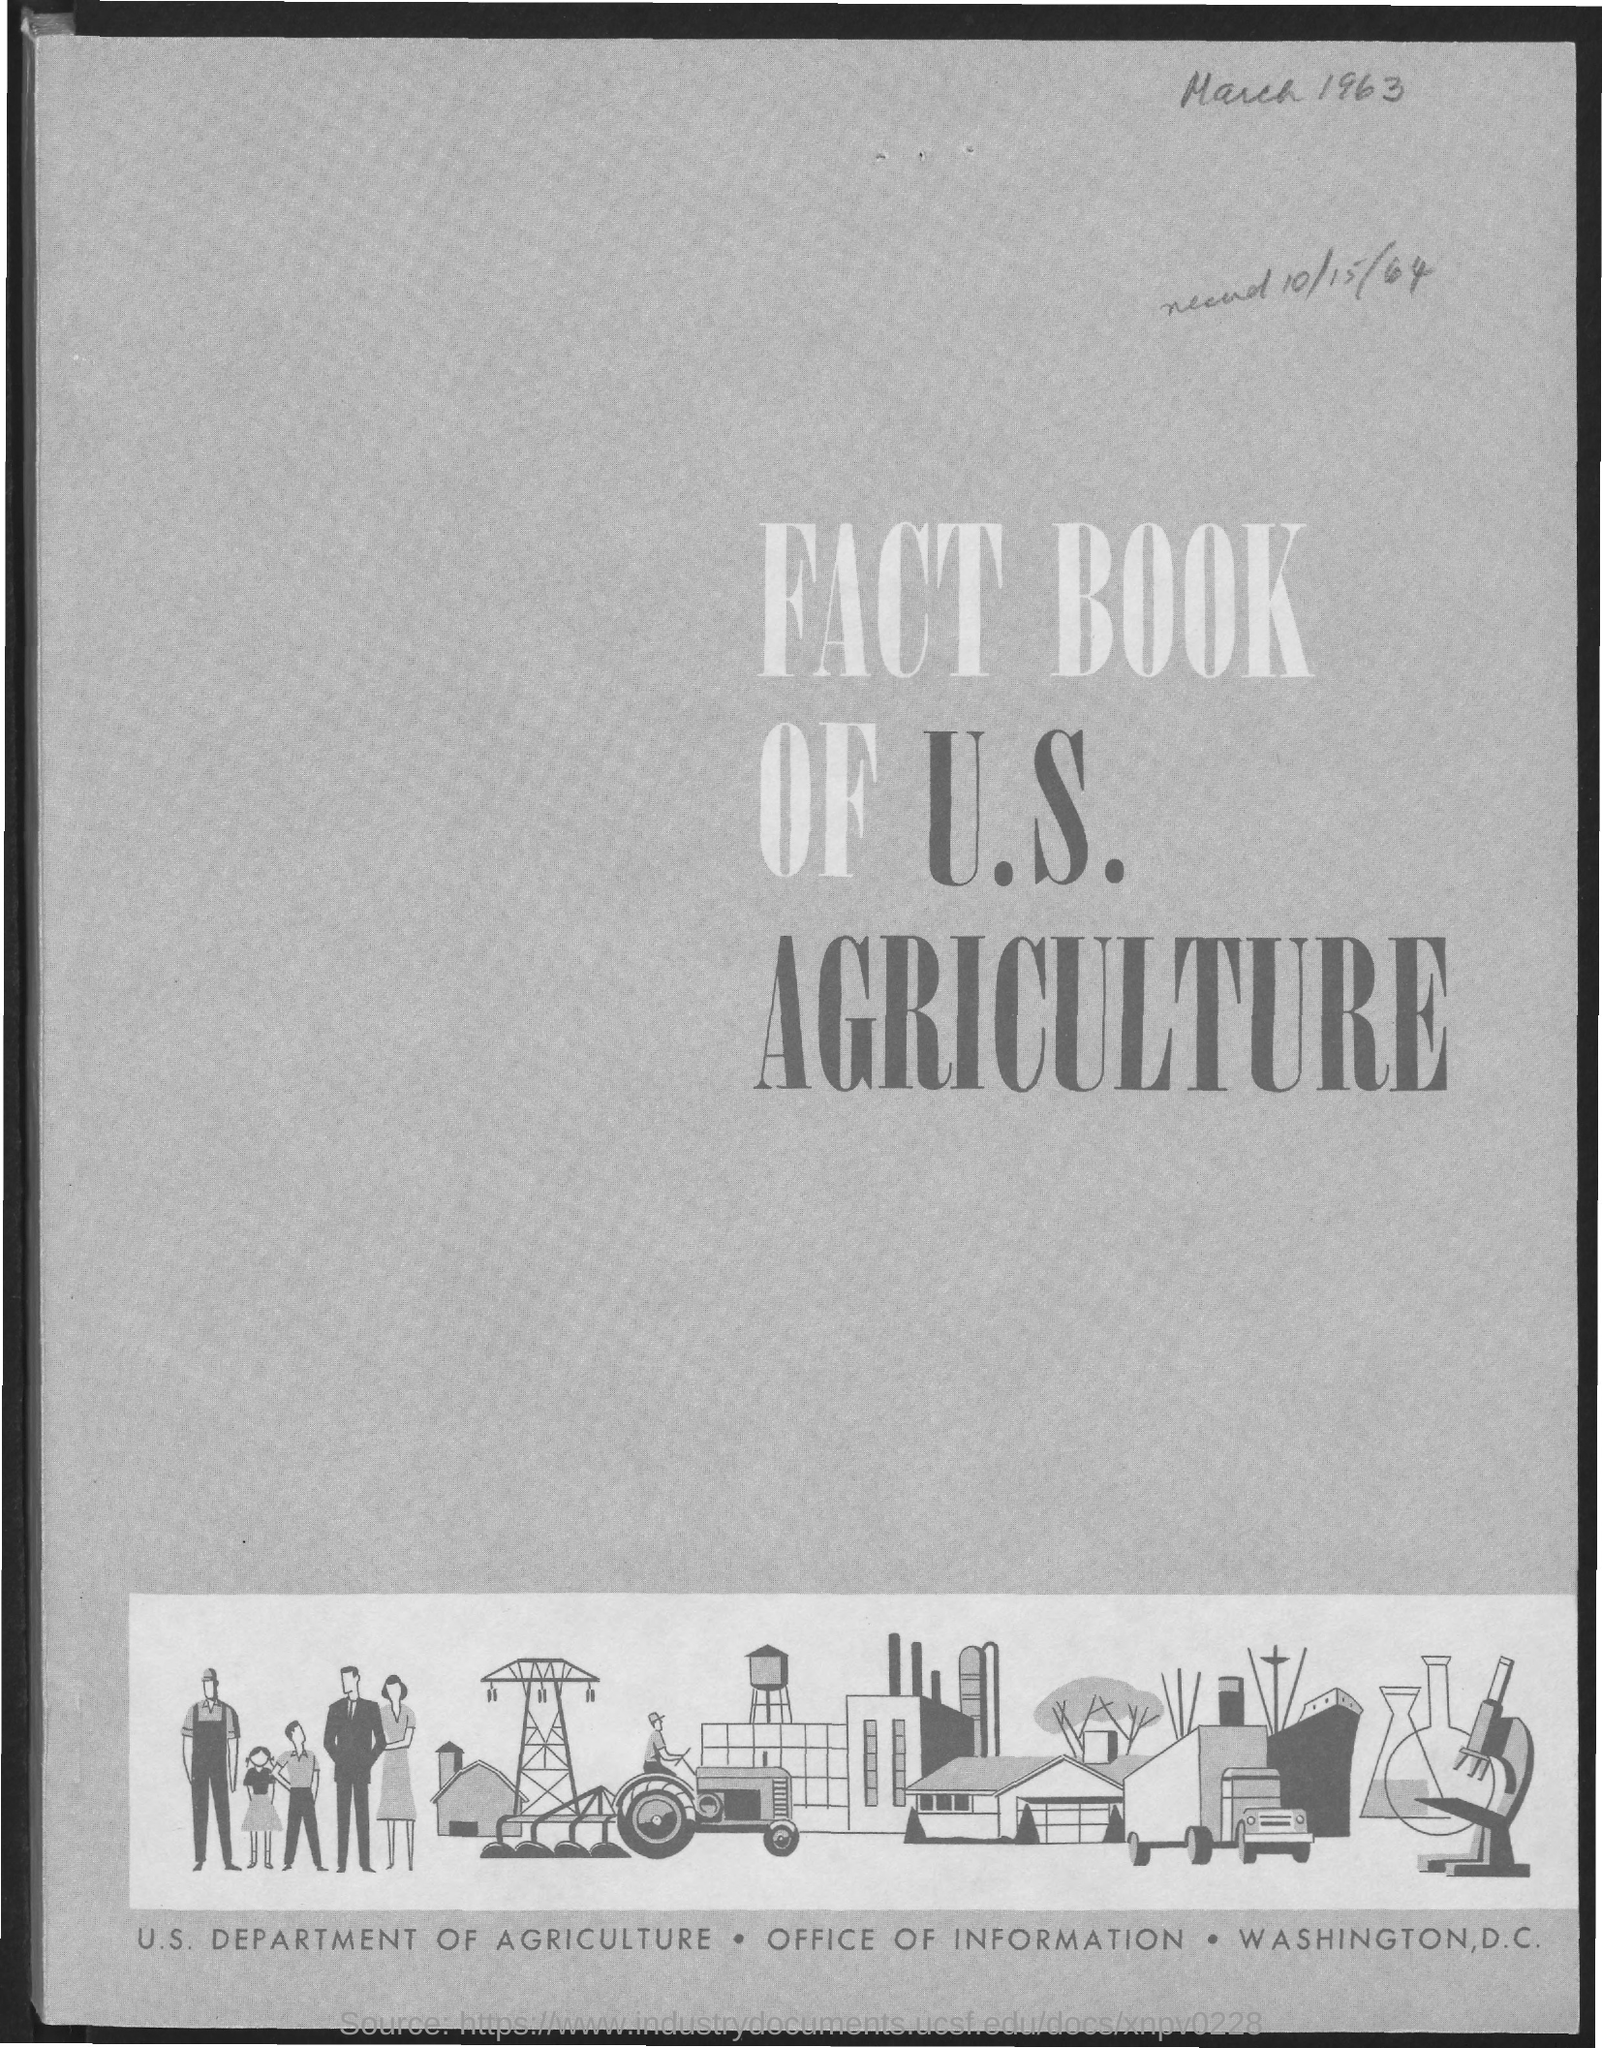Draw attention to some important aspects in this diagram. The FACT BOOK OF U.S. AGRICULTURE is a comprehensive publication that provides information about the agriculture industry in the United States. 